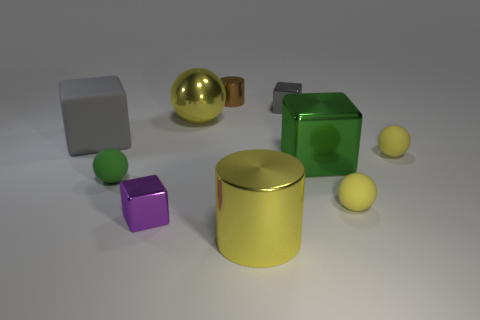Does the large cylinder have the same color as the big metal ball?
Your answer should be compact. Yes. Are the small gray thing and the big gray cube made of the same material?
Give a very brief answer. No. What number of yellow things are in front of the large green metallic thing and on the left side of the small gray shiny object?
Offer a terse response. 1. What shape is the gray thing that is the same size as the brown metallic cylinder?
Provide a succinct answer. Cube. The yellow cylinder has what size?
Ensure brevity in your answer.  Large. There is a small green object in front of the yellow metal thing that is behind the big cube that is left of the big green cube; what is its material?
Your answer should be compact. Rubber. What color is the small cylinder that is made of the same material as the small purple thing?
Ensure brevity in your answer.  Brown. What number of big gray matte objects are on the right side of the shiny cylinder in front of the small ball behind the green rubber object?
Your answer should be compact. 0. There is a large cylinder that is the same color as the metal ball; what is its material?
Keep it short and to the point. Metal. How many objects are either small green things that are left of the large yellow metal cylinder or green matte things?
Provide a succinct answer. 1. 